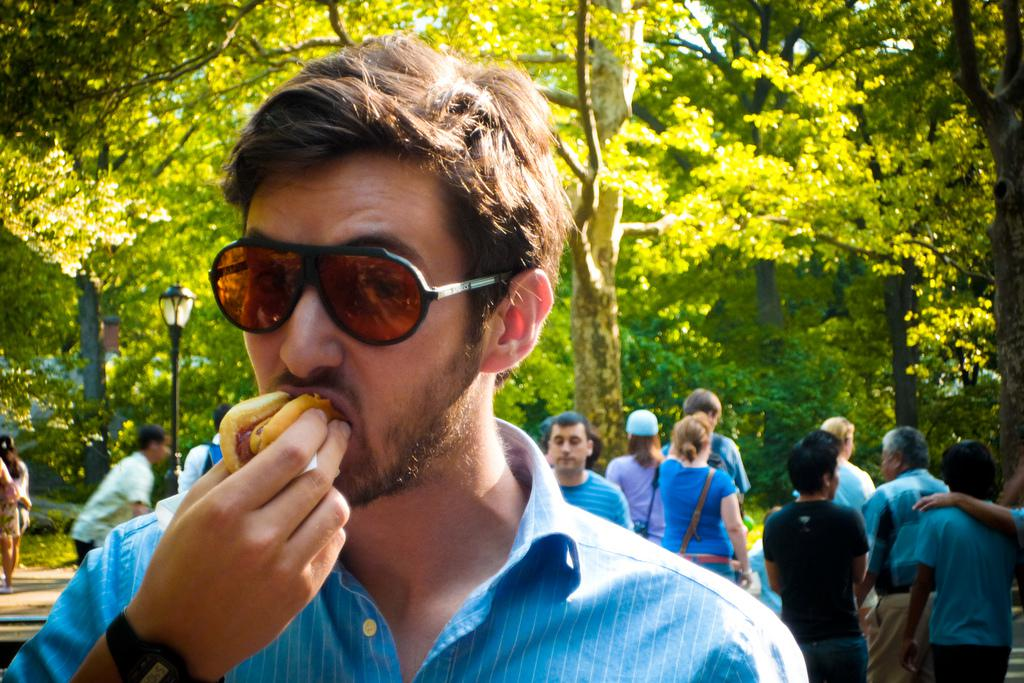Question: how much of the hotdog is left?
Choices:
A. A bite.
B. The whole thing.
C. Half.
D. A third.
Answer with the letter. Answer: C Question: what's see through?
Choices:
A. The man's reading glasses.
B. The woman's sun glasses.
C. The woman's reading glasses.
D. The man's sun glasses.
Answer with the letter. Answer: D Question: when was this picture taken?
Choices:
A. At dusk.
B. During the day.
C. At Dawn.
D. Nighttime.
Answer with the letter. Answer: B Question: where was the guy standing?
Choices:
A. In front of the grocery store.
B. By the hotdog cart.
C. In the ocean.
D. In front of the camera.
Answer with the letter. Answer: D Question: what was the guy eating?
Choices:
A. A slice of pizza.
B. Sushi.
C. A hotdog.
D. Salad.
Answer with the letter. Answer: C Question: how was the weather?
Choices:
A. Overcast.
B. Snowing.
C. Windy.
D. Sunny and clear.
Answer with the letter. Answer: D Question: where are the sunglasses?
Choices:
A. On the desk.
B. On the man's face.
C. On the pillow.
D. On a bag.
Answer with the letter. Answer: B Question: who is eating a hot dog?
Choices:
A. A lady.
B. A girl.
C. A man with sunglasses.
D. A boy.
Answer with the letter. Answer: C Question: what is on the hot dog?
Choices:
A. Milk.
B. Cinamon.
C. Sauce.
D. Mustard.
Answer with the letter. Answer: D Question: what color are the leaves?
Choices:
A. Yellow.
B. Red.
C. Orange.
D. Green.
Answer with the letter. Answer: D Question: what did the the guy have on his faces?
Choices:
A. Eye patch.
B. Mask.
C. Sunglasses.
D. Glasses.
Answer with the letter. Answer: C Question: what did the lady in blue have on her shoulder?
Choices:
A. Backpack.
B. A purse.
C. Bird.
D. A hand.
Answer with the letter. Answer: B Question: who is wearing a button up shirt?
Choices:
A. The man on the left.
B. The lady on the right.
C. The older man.
D. This man.
Answer with the letter. Answer: D Question: what is the man wearing?
Choices:
A. A suit.
B. A tie.
C. A blue shirt.
D. Board shorts.
Answer with the letter. Answer: C Question: who is wearing a digital watch?
Choices:
A. The girl.
B. The man.
C. The lady.
D. The Asian person.
Answer with the letter. Answer: B Question: who has brown hair?
Choices:
A. The man.
B. The girl.
C. The boy.
D. The person on the left.
Answer with the letter. Answer: A Question: what is he eating?
Choices:
A. A banana.
B. A hot dog.
C. Fries.
D. Steak.
Answer with the letter. Answer: B Question: who has a beard?
Choices:
A. An old man.
B. The man.
C. A lady.
D. A puppet.
Answer with the letter. Answer: B Question: who is eating hot dog?
Choices:
A. Man wearing wristwatch.
B. Woman wearing a raincoat.
C. Child sitting at the table.
D. Man sitting on a boat.
Answer with the letter. Answer: A Question: who is eating hot dog?
Choices:
A. A child at a ballgame.
B. Man looking at camera.
C. Woman walking her dog.
D. Man sitting at the table.
Answer with the letter. Answer: B Question: who is wearing sunglasses?
Choices:
A. One person.
B. Two people.
C. Three people.
D. Four people.
Answer with the letter. Answer: A 